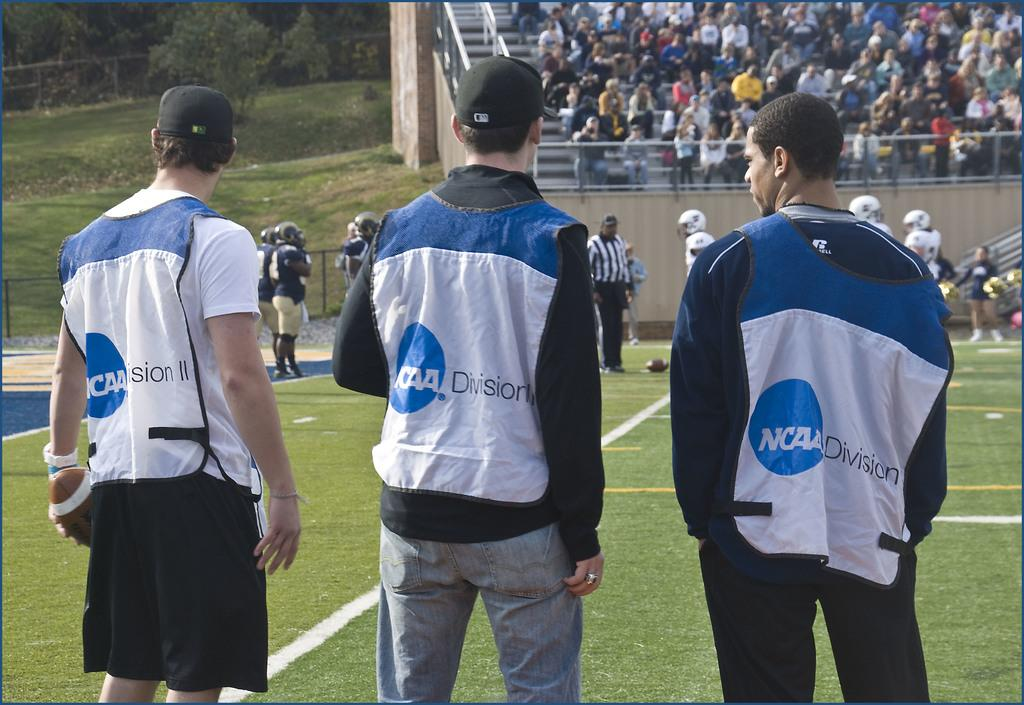<image>
Write a terse but informative summary of the picture. Three men facing forwards, they have the letters NCAA on their jackets. 